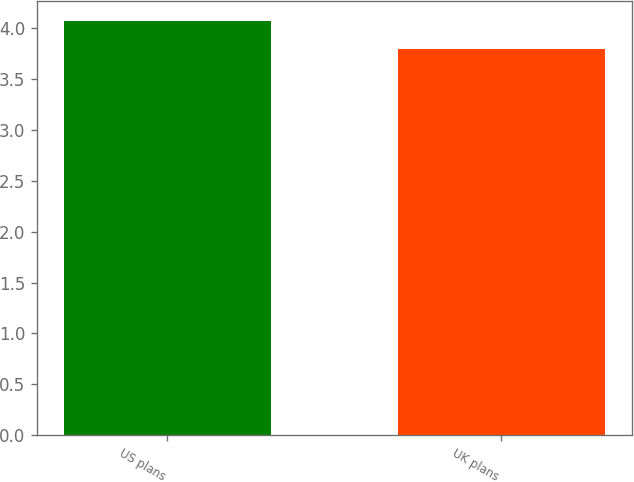<chart> <loc_0><loc_0><loc_500><loc_500><bar_chart><fcel>US plans<fcel>UK plans<nl><fcel>4.07<fcel>3.8<nl></chart> 